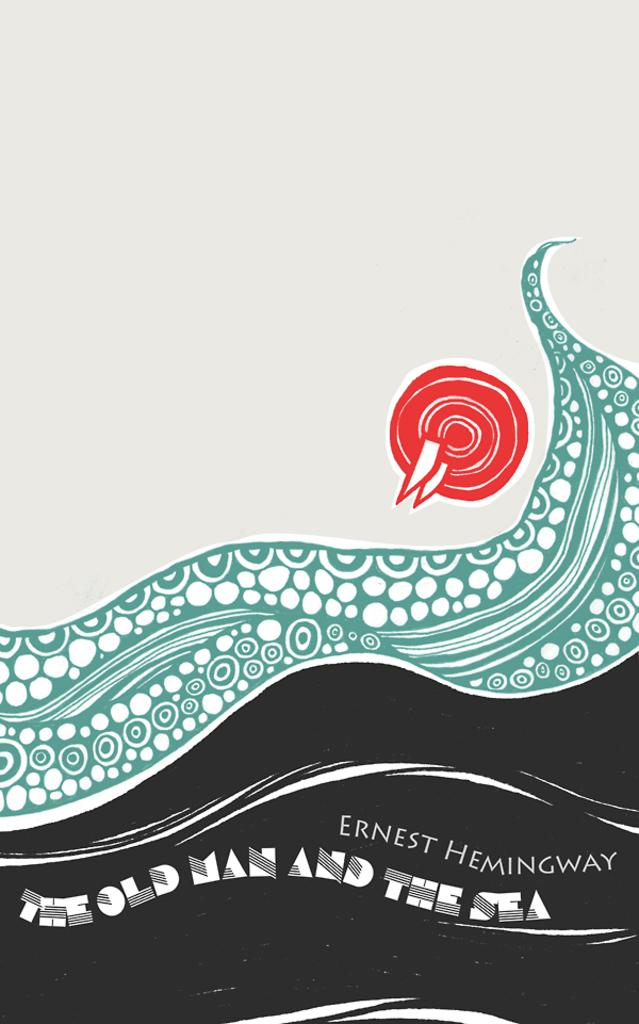What type of image is being described? The image is an animation. Where is the logo located in the image? The logo is on the right side of the image. What additional information can be found at the bottom of the image? There is text at the bottom of the image. What color is the tongue of the character in the image? There is no character or tongue present in the image; it is an animation with a logo and text. 